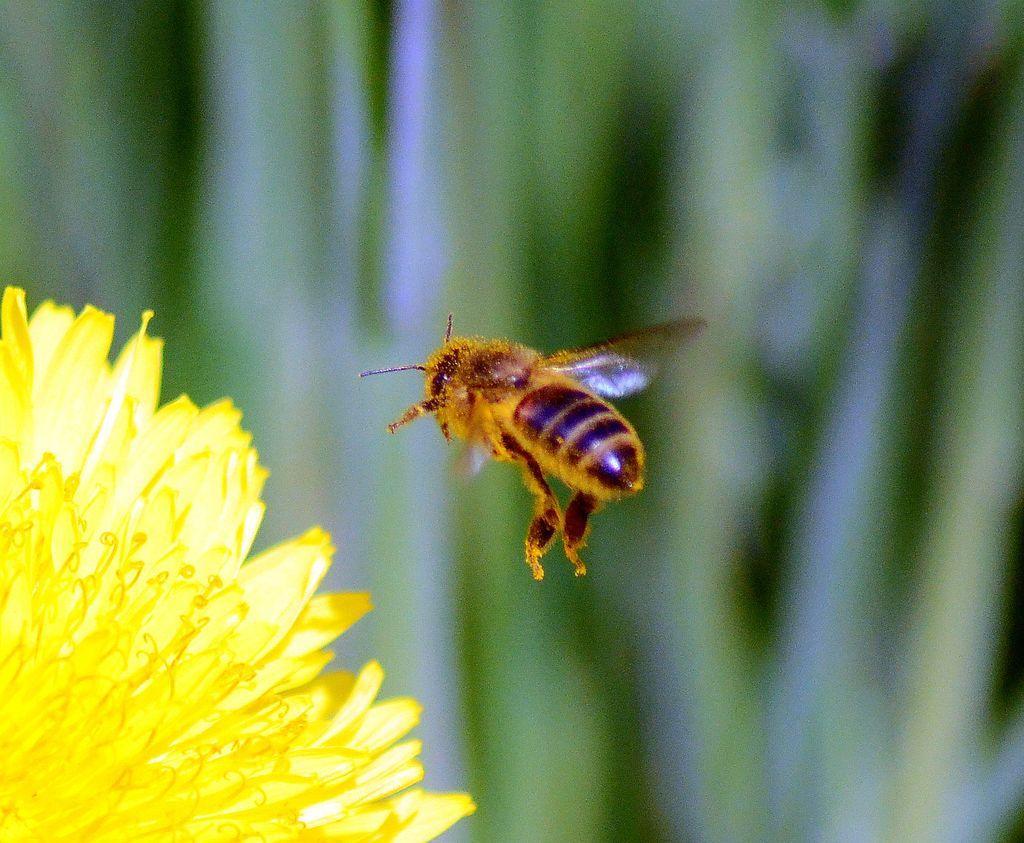How would you summarize this image in a sentence or two? In this image on the left side three is one flower and in the center there is one bee, and in the background there are some plants. 